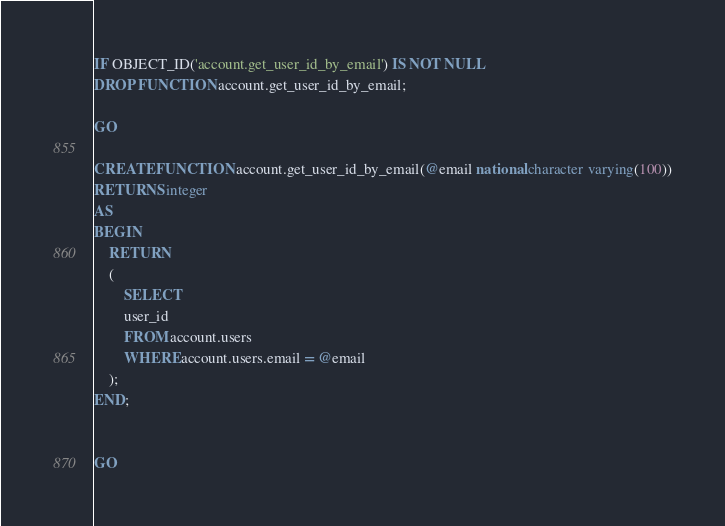Convert code to text. <code><loc_0><loc_0><loc_500><loc_500><_SQL_>IF OBJECT_ID('account.get_user_id_by_email') IS NOT NULL
DROP FUNCTION account.get_user_id_by_email;

GO

CREATE FUNCTION account.get_user_id_by_email(@email national character varying(100))
RETURNS integer
AS
BEGIN
    RETURN
    (
		SELECT
		user_id
		FROM account.users
		WHERE account.users.email = @email
	);
END;


GO</code> 